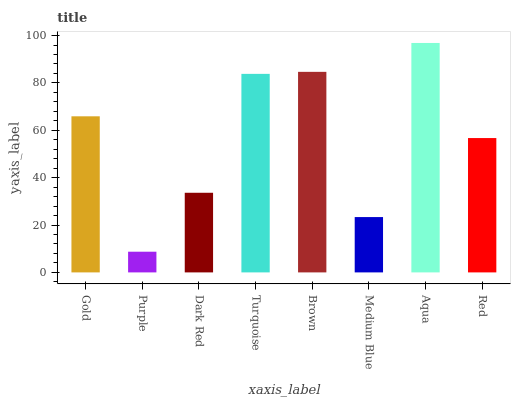Is Purple the minimum?
Answer yes or no. Yes. Is Aqua the maximum?
Answer yes or no. Yes. Is Dark Red the minimum?
Answer yes or no. No. Is Dark Red the maximum?
Answer yes or no. No. Is Dark Red greater than Purple?
Answer yes or no. Yes. Is Purple less than Dark Red?
Answer yes or no. Yes. Is Purple greater than Dark Red?
Answer yes or no. No. Is Dark Red less than Purple?
Answer yes or no. No. Is Gold the high median?
Answer yes or no. Yes. Is Red the low median?
Answer yes or no. Yes. Is Red the high median?
Answer yes or no. No. Is Medium Blue the low median?
Answer yes or no. No. 